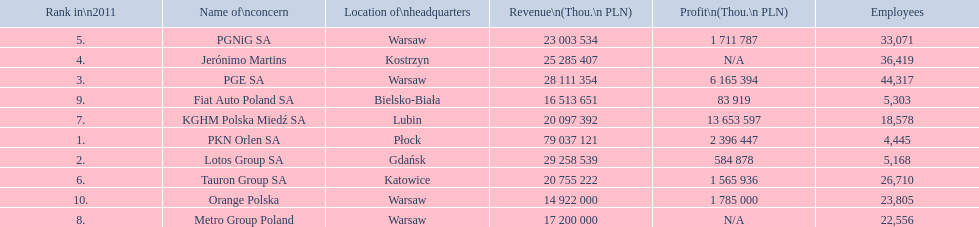What company has 28 111 354 thou.in revenue? PGE SA. What revenue does lotus group sa have? 29 258 539. Who has the next highest revenue than lotus group sa? PKN Orlen SA. 